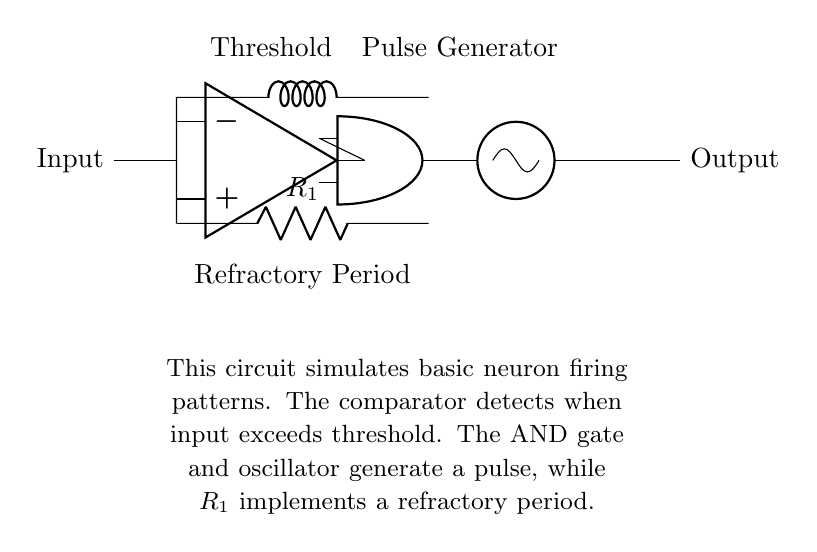What component generates the pulse in this circuit? The pulse generator is represented by an oscillator, which is responsible for generating the pulse output based on the input signals received from the AND gate.
Answer: Oscillator What does the resistor in the circuit represent? The resistor marked as R1 indicates a refractory period, which is a short duration after a neuron has fired during which it cannot fire again, simulating the biological characteristics of neurons.
Answer: Refractory period How many gates are used in the circuit? There are two specific types of logic gates in this circuit: the AND gate and the comparator that works similarly to a threshold detector, but primarily, the AND gate is highlighted for its role in pulse generation.
Answer: Two What is the function of the threshold comparator? The threshold comparator functions to detect when the input voltage exceeds a certain threshold level, which initiates the firing pattern in the neuron simulation.
Answer: Detects input threshold What does the output of the circuit represent? The output of the circuit simulates the firing pattern of a neuron, producing a pulse that reflects the processed input after the comparator and pulse generator act on it.
Answer: Neuron firing pattern 